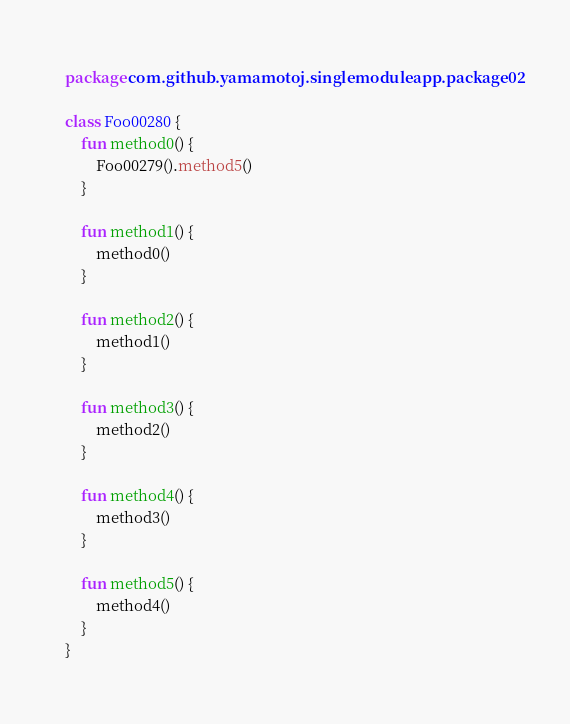Convert code to text. <code><loc_0><loc_0><loc_500><loc_500><_Kotlin_>package com.github.yamamotoj.singlemoduleapp.package02

class Foo00280 {
    fun method0() {
        Foo00279().method5()
    }

    fun method1() {
        method0()
    }

    fun method2() {
        method1()
    }

    fun method3() {
        method2()
    }

    fun method4() {
        method3()
    }

    fun method5() {
        method4()
    }
}
</code> 